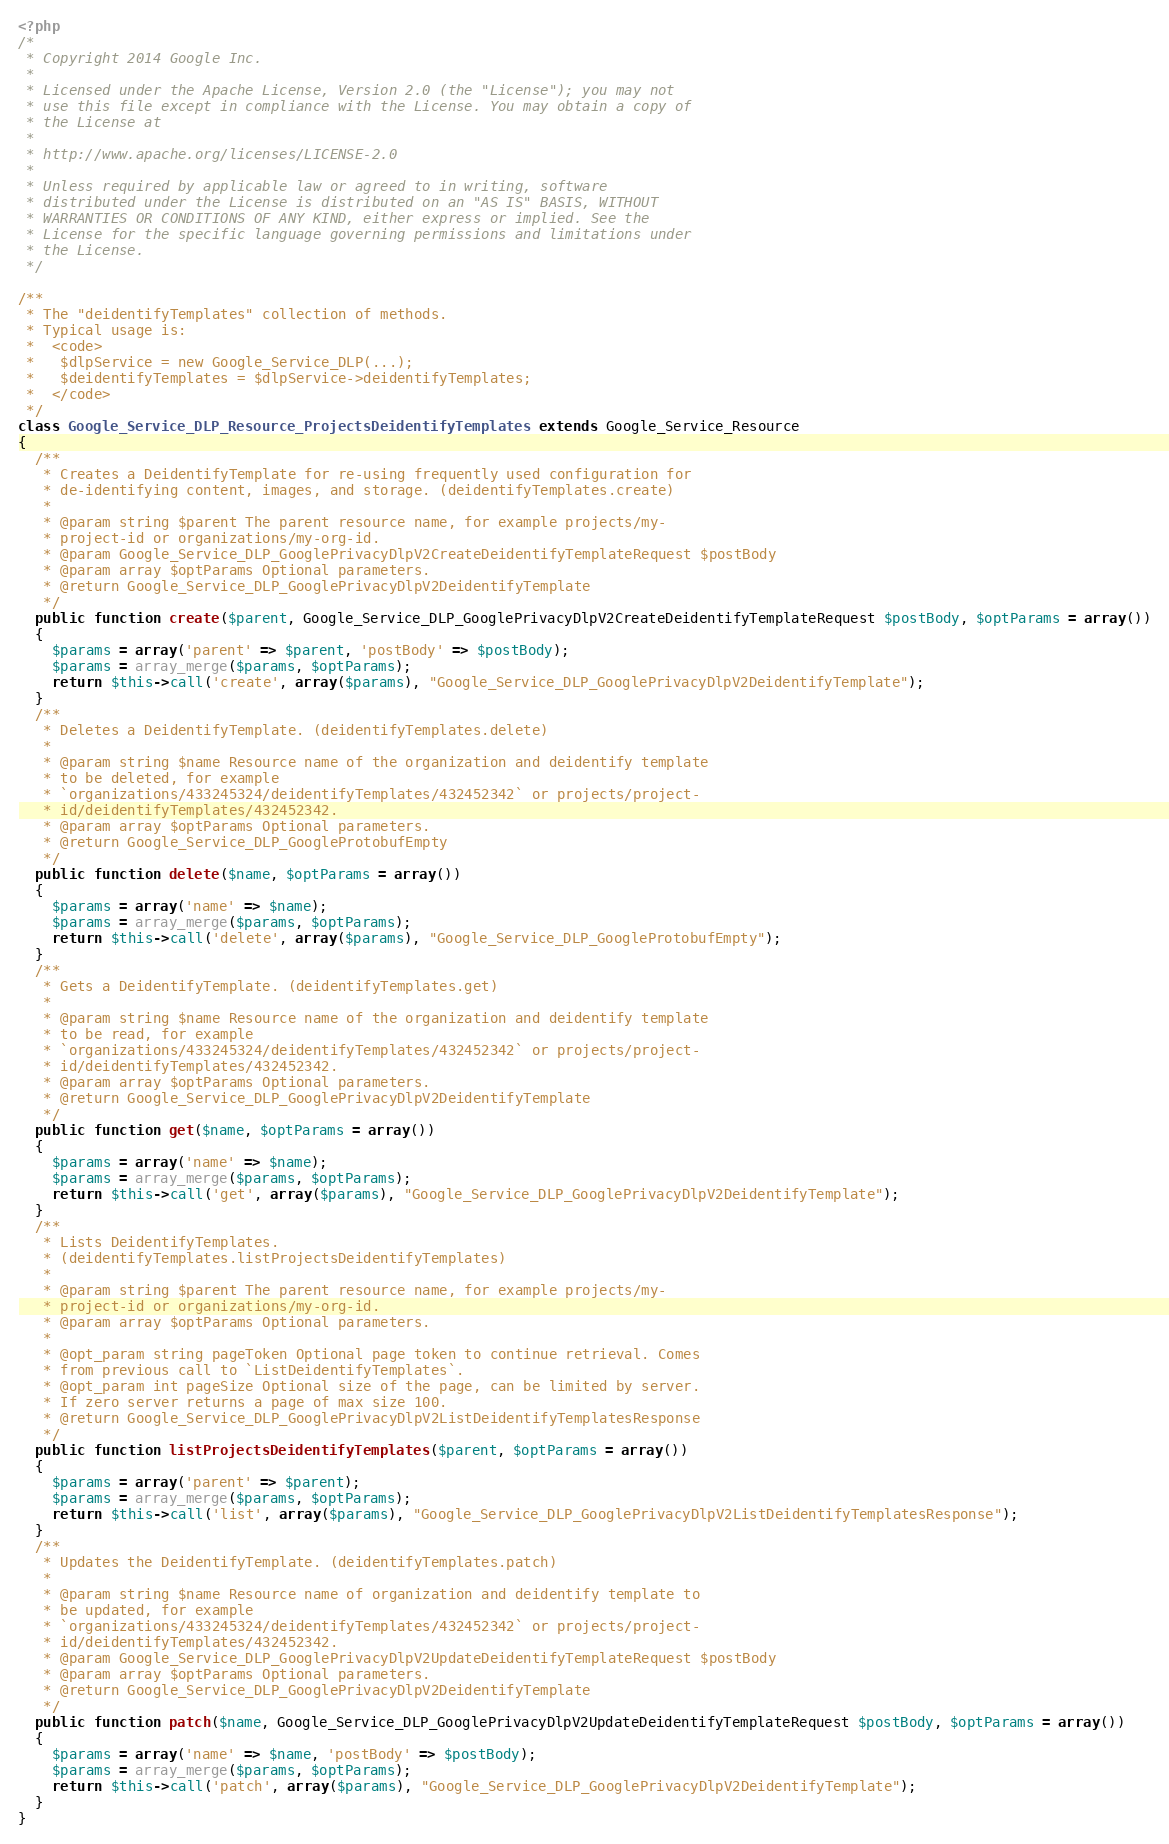<code> <loc_0><loc_0><loc_500><loc_500><_PHP_><?php
/*
 * Copyright 2014 Google Inc.
 *
 * Licensed under the Apache License, Version 2.0 (the "License"); you may not
 * use this file except in compliance with the License. You may obtain a copy of
 * the License at
 *
 * http://www.apache.org/licenses/LICENSE-2.0
 *
 * Unless required by applicable law or agreed to in writing, software
 * distributed under the License is distributed on an "AS IS" BASIS, WITHOUT
 * WARRANTIES OR CONDITIONS OF ANY KIND, either express or implied. See the
 * License for the specific language governing permissions and limitations under
 * the License.
 */

/**
 * The "deidentifyTemplates" collection of methods.
 * Typical usage is:
 *  <code>
 *   $dlpService = new Google_Service_DLP(...);
 *   $deidentifyTemplates = $dlpService->deidentifyTemplates;
 *  </code>
 */
class Google_Service_DLP_Resource_ProjectsDeidentifyTemplates extends Google_Service_Resource
{
  /**
   * Creates a DeidentifyTemplate for re-using frequently used configuration for
   * de-identifying content, images, and storage. (deidentifyTemplates.create)
   *
   * @param string $parent The parent resource name, for example projects/my-
   * project-id or organizations/my-org-id.
   * @param Google_Service_DLP_GooglePrivacyDlpV2CreateDeidentifyTemplateRequest $postBody
   * @param array $optParams Optional parameters.
   * @return Google_Service_DLP_GooglePrivacyDlpV2DeidentifyTemplate
   */
  public function create($parent, Google_Service_DLP_GooglePrivacyDlpV2CreateDeidentifyTemplateRequest $postBody, $optParams = array())
  {
    $params = array('parent' => $parent, 'postBody' => $postBody);
    $params = array_merge($params, $optParams);
    return $this->call('create', array($params), "Google_Service_DLP_GooglePrivacyDlpV2DeidentifyTemplate");
  }
  /**
   * Deletes a DeidentifyTemplate. (deidentifyTemplates.delete)
   *
   * @param string $name Resource name of the organization and deidentify template
   * to be deleted, for example
   * `organizations/433245324/deidentifyTemplates/432452342` or projects/project-
   * id/deidentifyTemplates/432452342.
   * @param array $optParams Optional parameters.
   * @return Google_Service_DLP_GoogleProtobufEmpty
   */
  public function delete($name, $optParams = array())
  {
    $params = array('name' => $name);
    $params = array_merge($params, $optParams);
    return $this->call('delete', array($params), "Google_Service_DLP_GoogleProtobufEmpty");
  }
  /**
   * Gets a DeidentifyTemplate. (deidentifyTemplates.get)
   *
   * @param string $name Resource name of the organization and deidentify template
   * to be read, for example
   * `organizations/433245324/deidentifyTemplates/432452342` or projects/project-
   * id/deidentifyTemplates/432452342.
   * @param array $optParams Optional parameters.
   * @return Google_Service_DLP_GooglePrivacyDlpV2DeidentifyTemplate
   */
  public function get($name, $optParams = array())
  {
    $params = array('name' => $name);
    $params = array_merge($params, $optParams);
    return $this->call('get', array($params), "Google_Service_DLP_GooglePrivacyDlpV2DeidentifyTemplate");
  }
  /**
   * Lists DeidentifyTemplates.
   * (deidentifyTemplates.listProjectsDeidentifyTemplates)
   *
   * @param string $parent The parent resource name, for example projects/my-
   * project-id or organizations/my-org-id.
   * @param array $optParams Optional parameters.
   *
   * @opt_param string pageToken Optional page token to continue retrieval. Comes
   * from previous call to `ListDeidentifyTemplates`.
   * @opt_param int pageSize Optional size of the page, can be limited by server.
   * If zero server returns a page of max size 100.
   * @return Google_Service_DLP_GooglePrivacyDlpV2ListDeidentifyTemplatesResponse
   */
  public function listProjectsDeidentifyTemplates($parent, $optParams = array())
  {
    $params = array('parent' => $parent);
    $params = array_merge($params, $optParams);
    return $this->call('list', array($params), "Google_Service_DLP_GooglePrivacyDlpV2ListDeidentifyTemplatesResponse");
  }
  /**
   * Updates the DeidentifyTemplate. (deidentifyTemplates.patch)
   *
   * @param string $name Resource name of organization and deidentify template to
   * be updated, for example
   * `organizations/433245324/deidentifyTemplates/432452342` or projects/project-
   * id/deidentifyTemplates/432452342.
   * @param Google_Service_DLP_GooglePrivacyDlpV2UpdateDeidentifyTemplateRequest $postBody
   * @param array $optParams Optional parameters.
   * @return Google_Service_DLP_GooglePrivacyDlpV2DeidentifyTemplate
   */
  public function patch($name, Google_Service_DLP_GooglePrivacyDlpV2UpdateDeidentifyTemplateRequest $postBody, $optParams = array())
  {
    $params = array('name' => $name, 'postBody' => $postBody);
    $params = array_merge($params, $optParams);
    return $this->call('patch', array($params), "Google_Service_DLP_GooglePrivacyDlpV2DeidentifyTemplate");
  }
}
</code> 